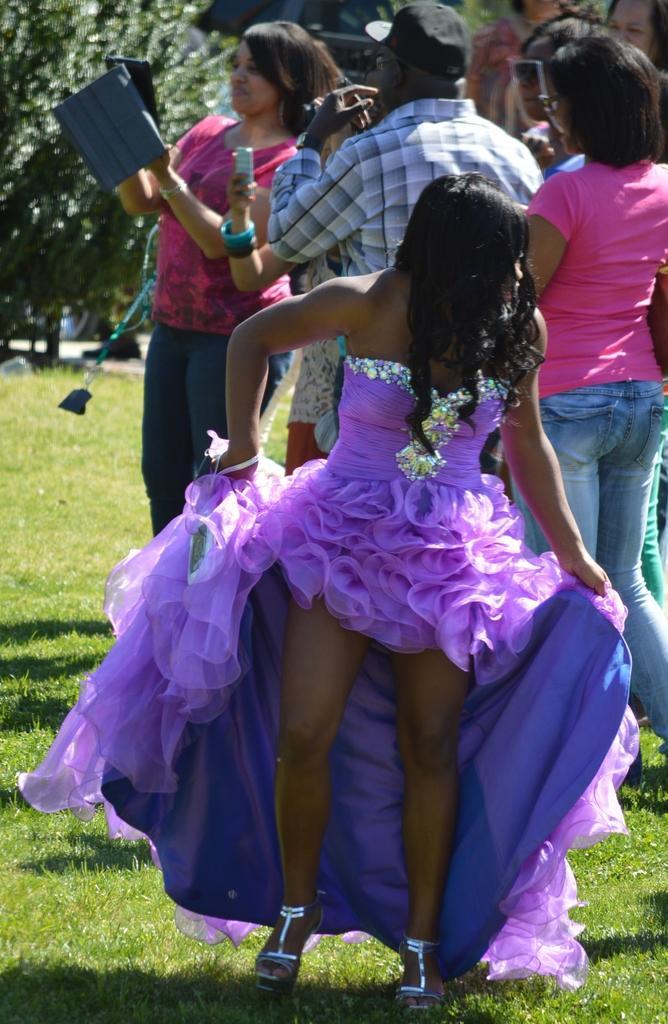How would you summarize this image in a sentence or two? In this image there is a girl in the middle who is holding her frock. In the background there are two persons who are taking the pictures with the mobiles. On the right side top there are few people standing on the ground. On the left side top there is a tree. 